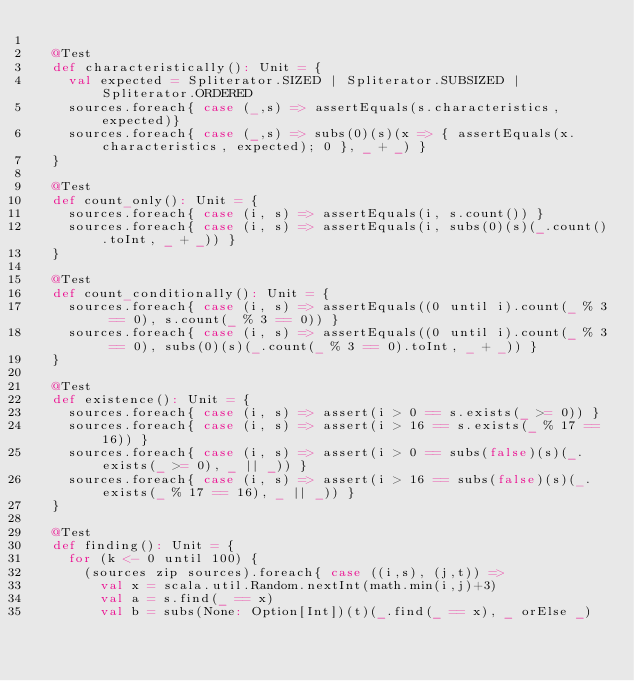Convert code to text. <code><loc_0><loc_0><loc_500><loc_500><_Scala_>
  @Test
  def characteristically(): Unit = {
    val expected = Spliterator.SIZED | Spliterator.SUBSIZED | Spliterator.ORDERED
    sources.foreach{ case (_,s) => assertEquals(s.characteristics, expected)}
    sources.foreach{ case (_,s) => subs(0)(s)(x => { assertEquals(x.characteristics, expected); 0 }, _ + _) }
  }

  @Test
  def count_only(): Unit = {
    sources.foreach{ case (i, s) => assertEquals(i, s.count()) }
    sources.foreach{ case (i, s) => assertEquals(i, subs(0)(s)(_.count().toInt, _ + _)) }
  }

  @Test
  def count_conditionally(): Unit = {
    sources.foreach{ case (i, s) => assertEquals((0 until i).count(_ % 3 == 0), s.count(_ % 3 == 0)) }
    sources.foreach{ case (i, s) => assertEquals((0 until i).count(_ % 3 == 0), subs(0)(s)(_.count(_ % 3 == 0).toInt, _ + _)) }
  }

  @Test
  def existence(): Unit = {
    sources.foreach{ case (i, s) => assert(i > 0 == s.exists(_ >= 0)) }
    sources.foreach{ case (i, s) => assert(i > 16 == s.exists(_ % 17 == 16)) }
    sources.foreach{ case (i, s) => assert(i > 0 == subs(false)(s)(_.exists(_ >= 0), _ || _)) }
    sources.foreach{ case (i, s) => assert(i > 16 == subs(false)(s)(_.exists(_ % 17 == 16), _ || _)) }
  }

  @Test
  def finding(): Unit = {
    for (k <- 0 until 100) {
      (sources zip sources).foreach{ case ((i,s), (j,t)) =>
        val x = scala.util.Random.nextInt(math.min(i,j)+3)
        val a = s.find(_ == x)
        val b = subs(None: Option[Int])(t)(_.find(_ == x), _ orElse _)</code> 